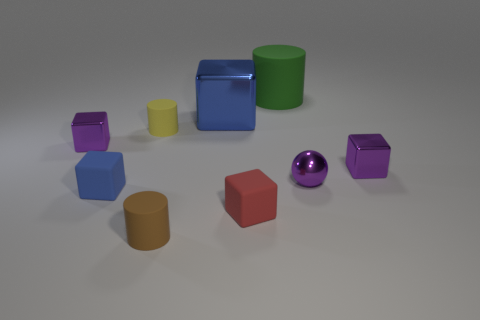Subtract all purple cylinders. Subtract all purple balls. How many cylinders are left? 3 Subtract all brown spheres. How many purple cylinders are left? 0 Add 1 small yellows. How many objects exist? 0 Subtract all large cyan metallic balls. Subtract all small purple metallic things. How many objects are left? 6 Add 7 tiny matte blocks. How many tiny matte blocks are left? 9 Add 5 matte things. How many matte things exist? 10 Add 1 small rubber balls. How many objects exist? 10 Subtract all green cylinders. How many cylinders are left? 2 Subtract all big rubber cylinders. How many cylinders are left? 2 Subtract 0 cyan cubes. How many objects are left? 9 